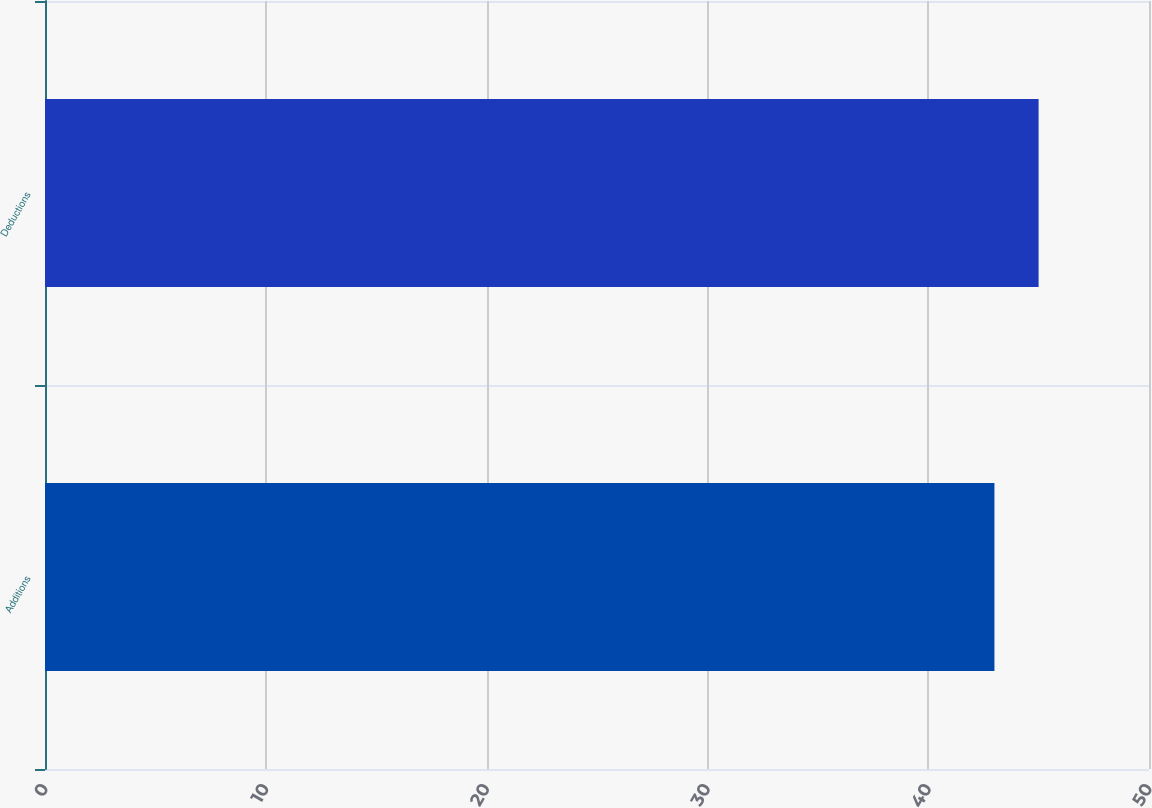Convert chart. <chart><loc_0><loc_0><loc_500><loc_500><bar_chart><fcel>Additions<fcel>Deductions<nl><fcel>43<fcel>45<nl></chart> 